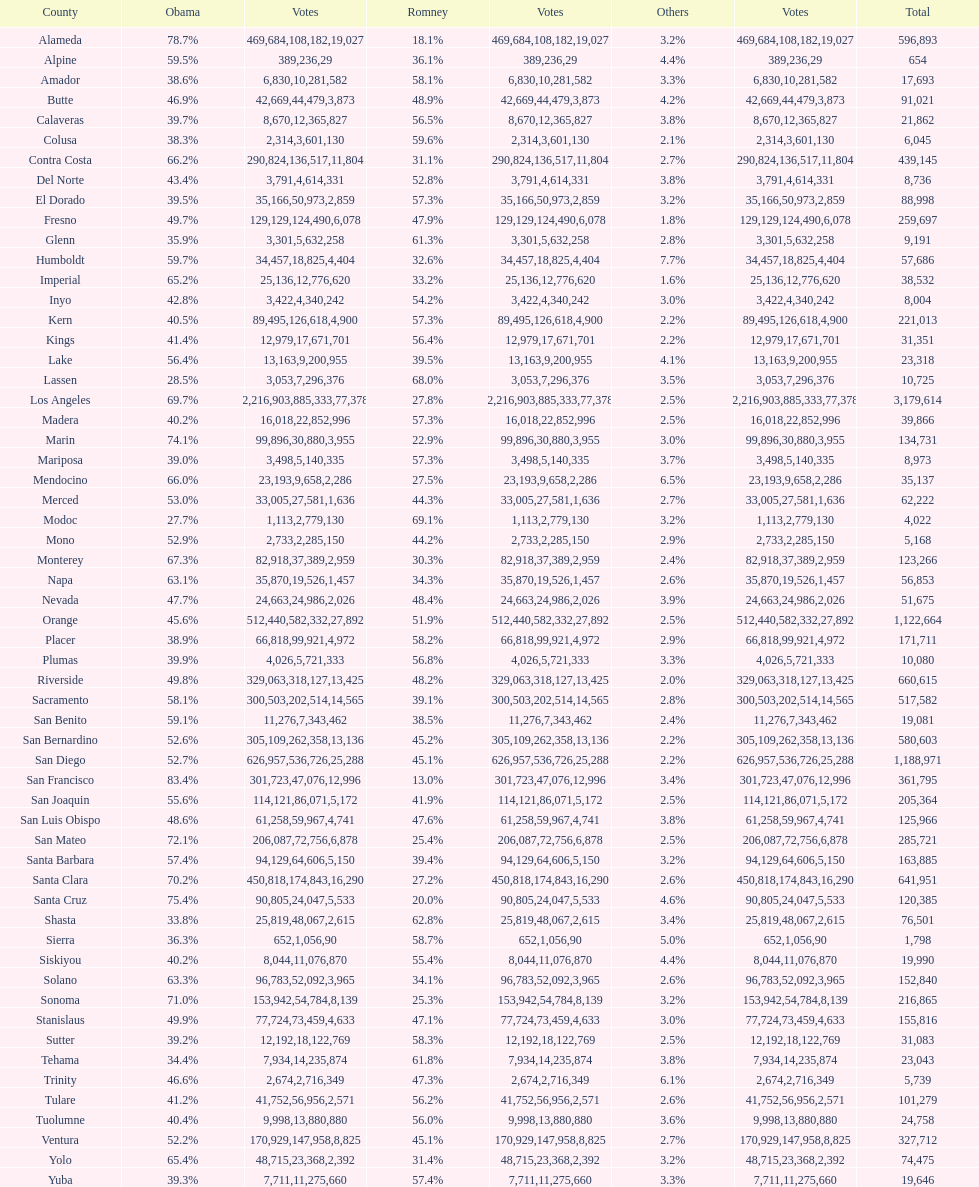How many counties gave obama 75% or more of their votes? 3. 